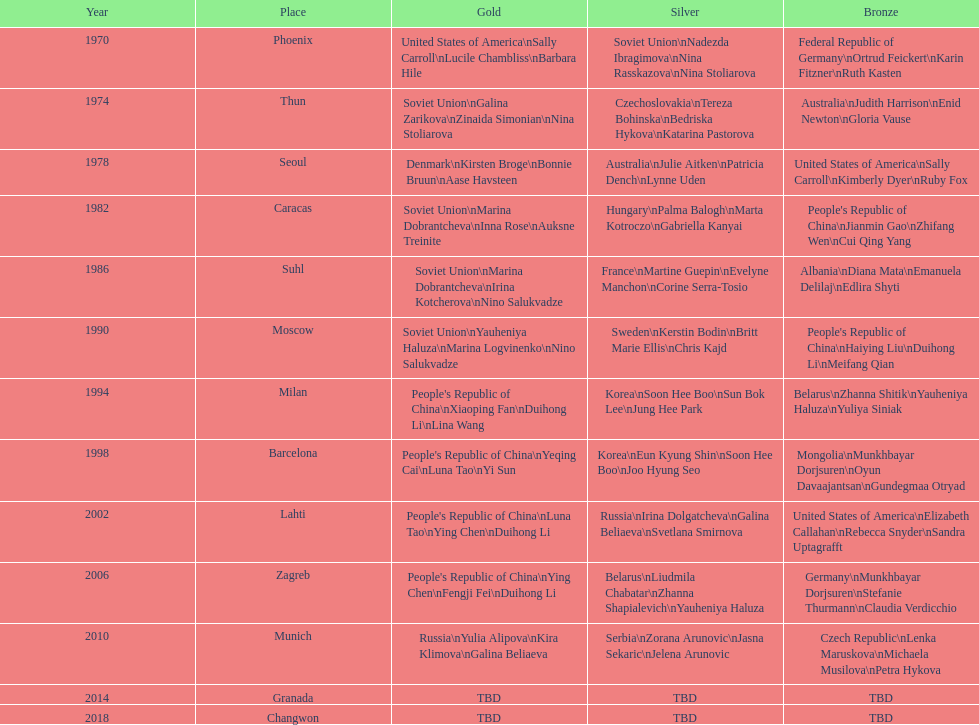Who is mentioned right before bonnie bruun in the gold column? Kirsten Broge. 